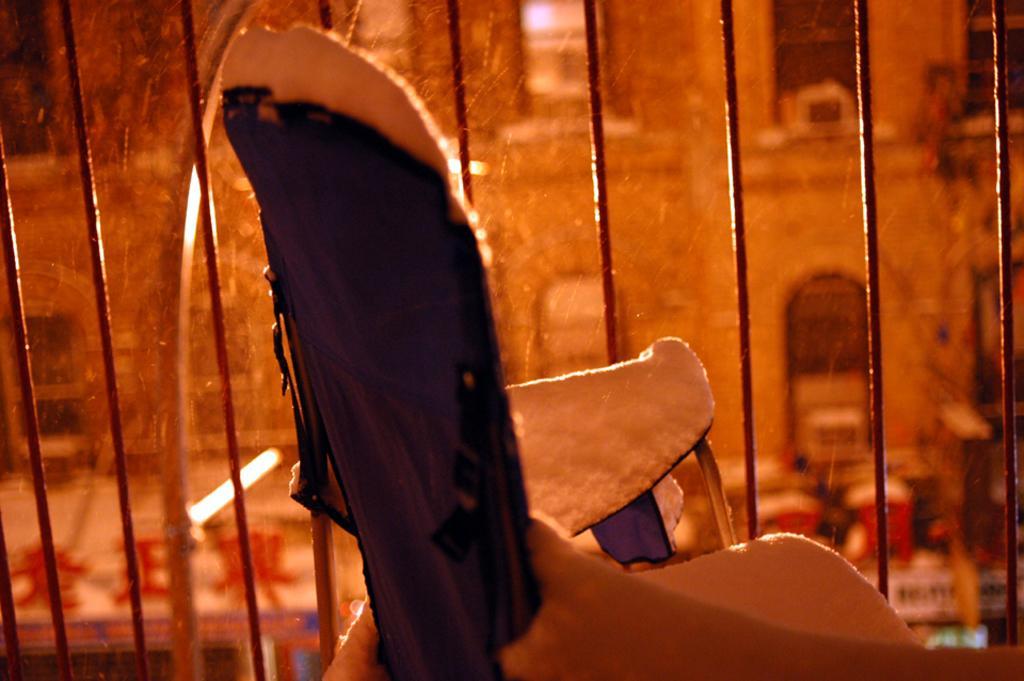Describe this image in one or two sentences. In this picture I can see a metal grill and I can see a building in the back and looks like a cardboard and a black cloth on it. 